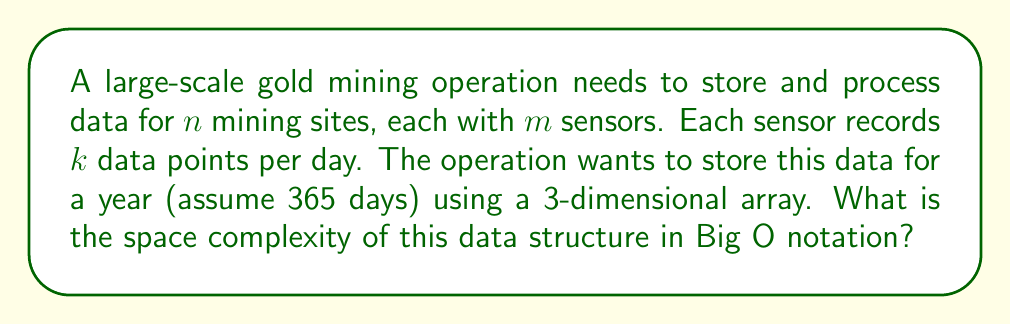Could you help me with this problem? Let's break down the problem step-by-step:

1) We have $n$ mining sites, which forms the first dimension of our 3D array.

2) Each site has $m$ sensors, forming the second dimension.

3) Each sensor records $k$ data points per day for 365 days, forming the third dimension.

4) The total number of elements in this 3D array would be:

   $n \times m \times (k \times 365)$

5) In Big O notation, we typically express complexity in terms of the input variables. Here, our input variables are $n$, $m$, and $k$. The constant 365 doesn't affect the overall complexity class.

6) Therefore, the space complexity can be expressed as $O(n \times m \times k)$.

This represents the worst-case space complexity, as it accounts for storing data from all sites, all sensors, and all data points throughout the year.
Answer: $O(n \times m \times k)$ 